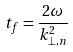<formula> <loc_0><loc_0><loc_500><loc_500>t _ { f } = \frac { 2 \omega } { k _ { \perp , n } ^ { 2 } }</formula> 